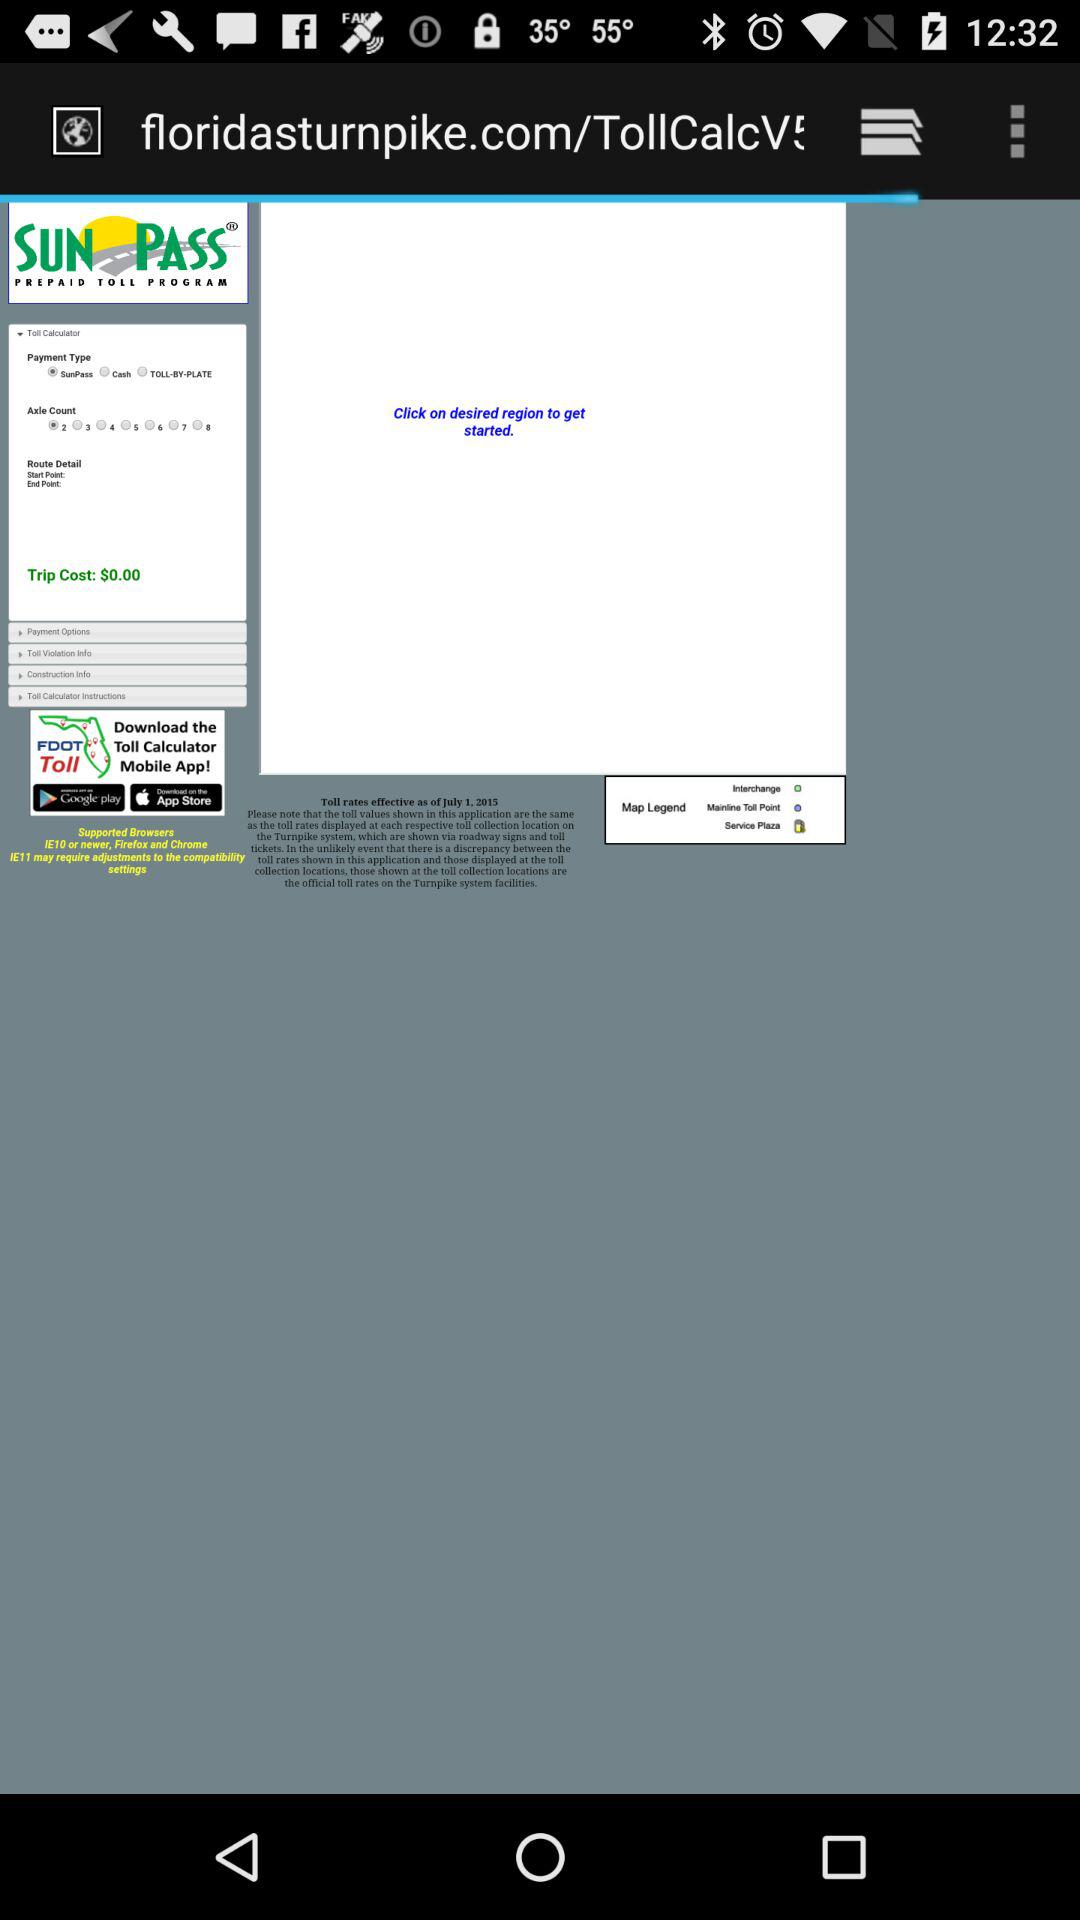What is the trip cost? The trip cost is $0.00. 